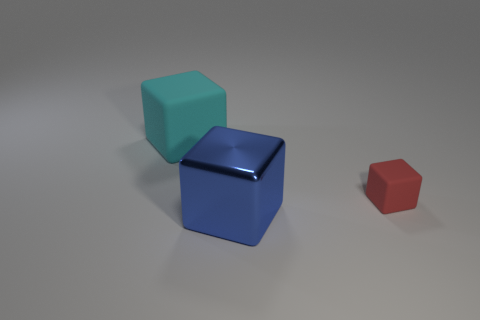Add 3 cyan things. How many objects exist? 6 Add 1 large cyan rubber things. How many large cyan rubber things are left? 2 Add 3 blue metallic objects. How many blue metallic objects exist? 4 Subtract 1 blue cubes. How many objects are left? 2 Subtract all cubes. Subtract all big cyan metal balls. How many objects are left? 0 